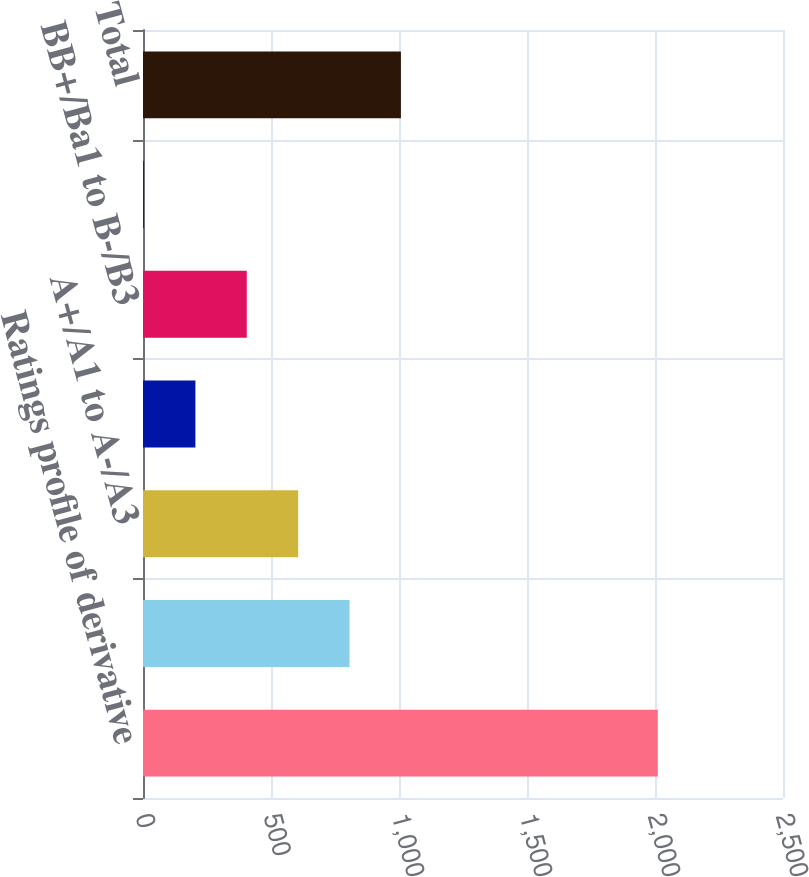Convert chart. <chart><loc_0><loc_0><loc_500><loc_500><bar_chart><fcel>Ratings profile of derivative<fcel>AAA/Aaa to AA-/Aa3<fcel>A+/A1 to A-/A3<fcel>BBB+/Baa1 to BBB-/Baa3<fcel>BB+/Ba1 to B-/B3<fcel>CCC+/Caa1 and below<fcel>Total<nl><fcel>2011<fcel>806.8<fcel>606.1<fcel>204.7<fcel>405.4<fcel>4<fcel>1007.5<nl></chart> 